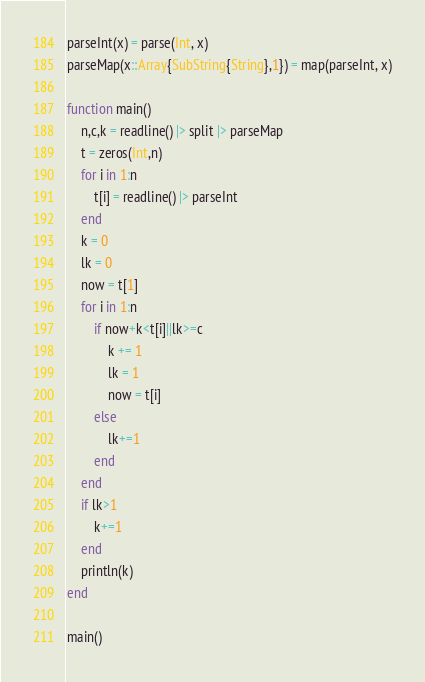<code> <loc_0><loc_0><loc_500><loc_500><_Julia_>parseInt(x) = parse(Int, x)
parseMap(x::Array{SubString{String},1}) = map(parseInt, x)

function main()
	n,c,k = readline() |> split |> parseMap
	t = zeros(Int,n)
	for i in 1:n
		t[i] = readline() |> parseInt
	end
	k = 0
	lk = 0
	now = t[1]
	for i in 1:n
		if now+k<t[i]||lk>=c
			k += 1
			lk = 1
			now = t[i]
		else
			lk+=1
		end
	end
	if lk>1
		k+=1
	end
	println(k)
end

main()</code> 